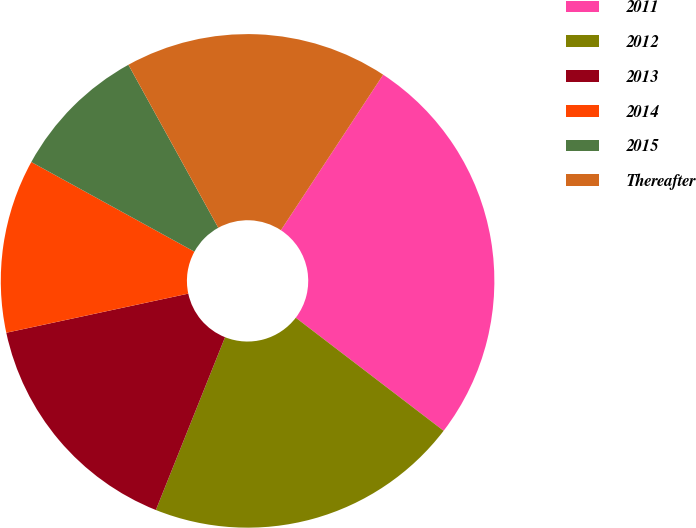<chart> <loc_0><loc_0><loc_500><loc_500><pie_chart><fcel>2011<fcel>2012<fcel>2013<fcel>2014<fcel>2015<fcel>Thereafter<nl><fcel>26.13%<fcel>20.67%<fcel>15.57%<fcel>11.37%<fcel>8.98%<fcel>17.28%<nl></chart> 